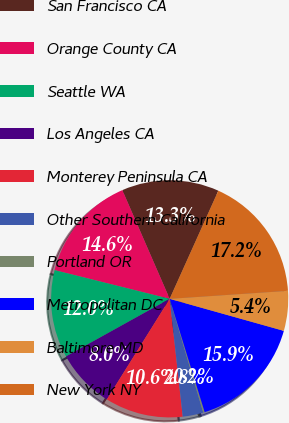Convert chart to OTSL. <chart><loc_0><loc_0><loc_500><loc_500><pie_chart><fcel>San Francisco CA<fcel>Orange County CA<fcel>Seattle WA<fcel>Los Angeles CA<fcel>Monterey Peninsula CA<fcel>Other Southern California<fcel>Portland OR<fcel>Metropolitan DC<fcel>Baltimore MD<fcel>New York NY<nl><fcel>13.27%<fcel>14.57%<fcel>11.96%<fcel>8.04%<fcel>10.65%<fcel>2.81%<fcel>0.2%<fcel>15.88%<fcel>5.43%<fcel>17.19%<nl></chart> 